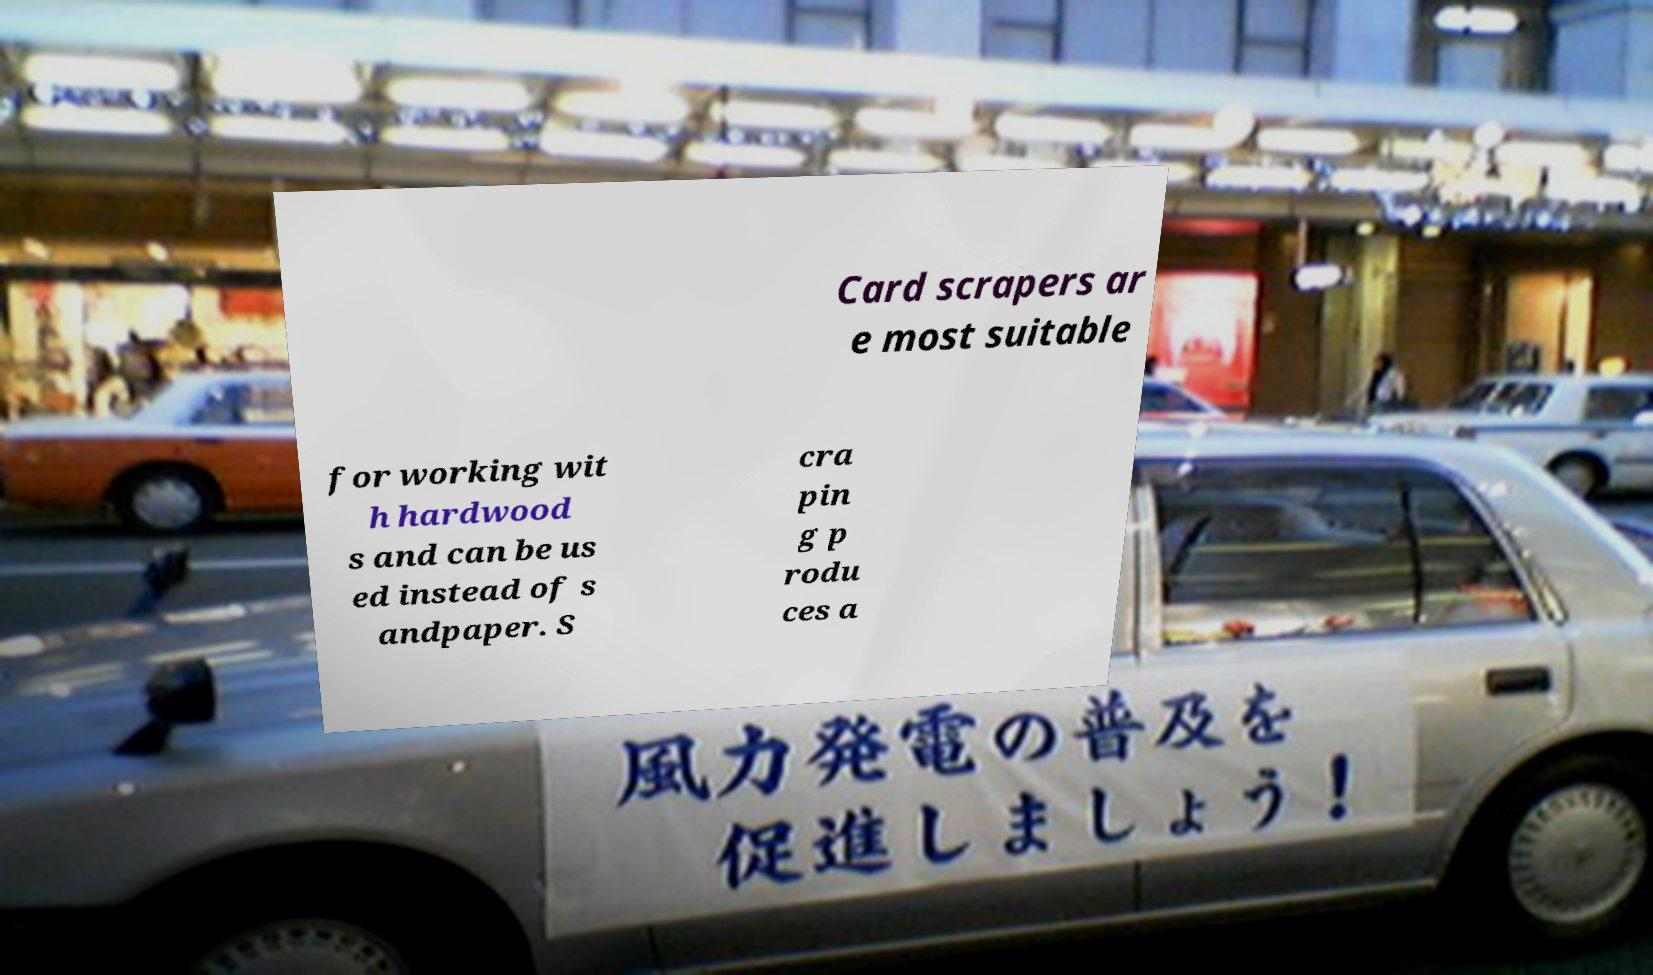Can you read and provide the text displayed in the image?This photo seems to have some interesting text. Can you extract and type it out for me? Card scrapers ar e most suitable for working wit h hardwood s and can be us ed instead of s andpaper. S cra pin g p rodu ces a 